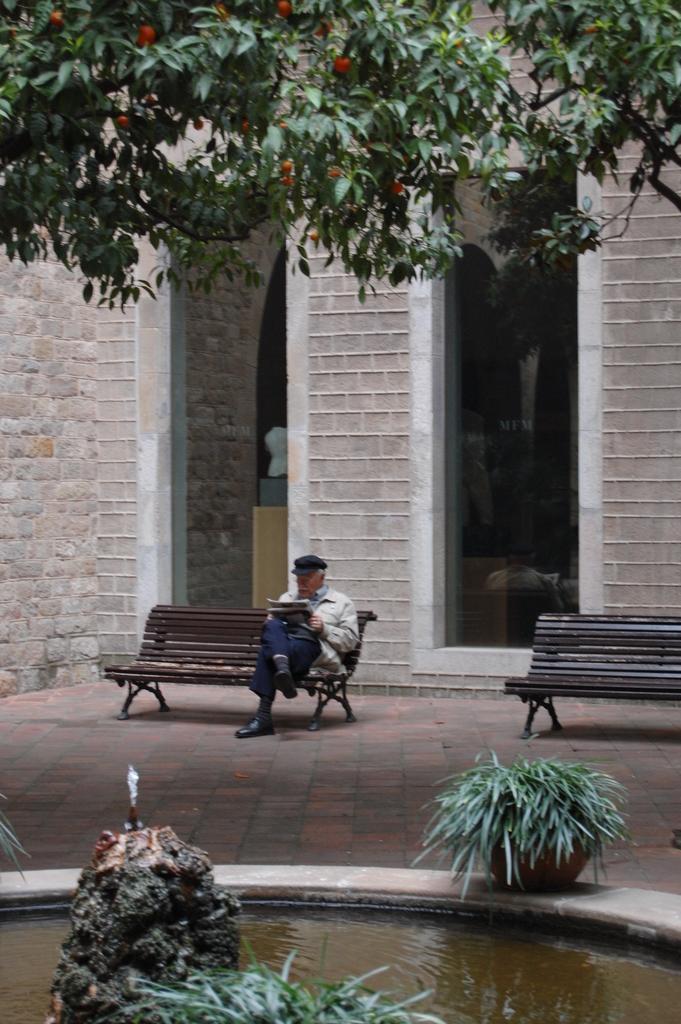Can you describe this image briefly? This picture is clicked outside a building. There are benches and a man is sitting on it reading a newspaper. In the front there is water and flower pots. There is a tree in the image. In the background there is a building.  